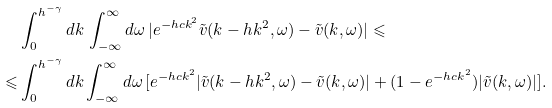Convert formula to latex. <formula><loc_0><loc_0><loc_500><loc_500>& \int _ { 0 } ^ { h ^ { - \gamma } } d k \, \int _ { - \infty } ^ { \infty } d \omega \, | e ^ { - h c k ^ { 2 } } \tilde { v } ( k - h k ^ { 2 } , \omega ) - \tilde { v } ( k , \omega ) | \leqslant \\ \leqslant & \int _ { 0 } ^ { h ^ { - \gamma } } d k \int _ { - \infty } ^ { \infty } d \omega \, [ e ^ { - h c k ^ { 2 } } | \tilde { v } ( k - h k ^ { 2 } , \omega ) - \tilde { v } ( k , \omega ) | + ( 1 - e ^ { - h c k ^ { 2 } } ) | \tilde { v } ( k , \omega ) | ] .</formula> 